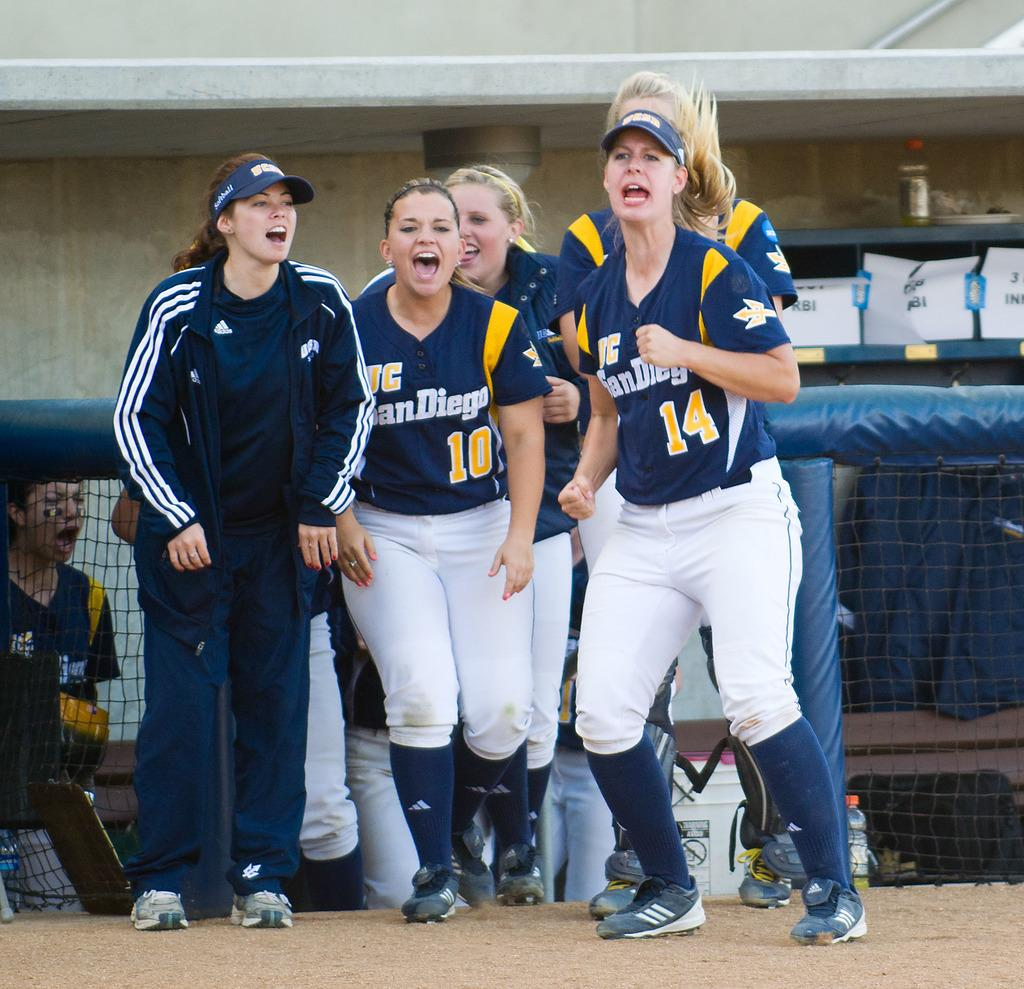<image>
Offer a succinct explanation of the picture presented. A group of women for the team of San Diego are yelling together. 